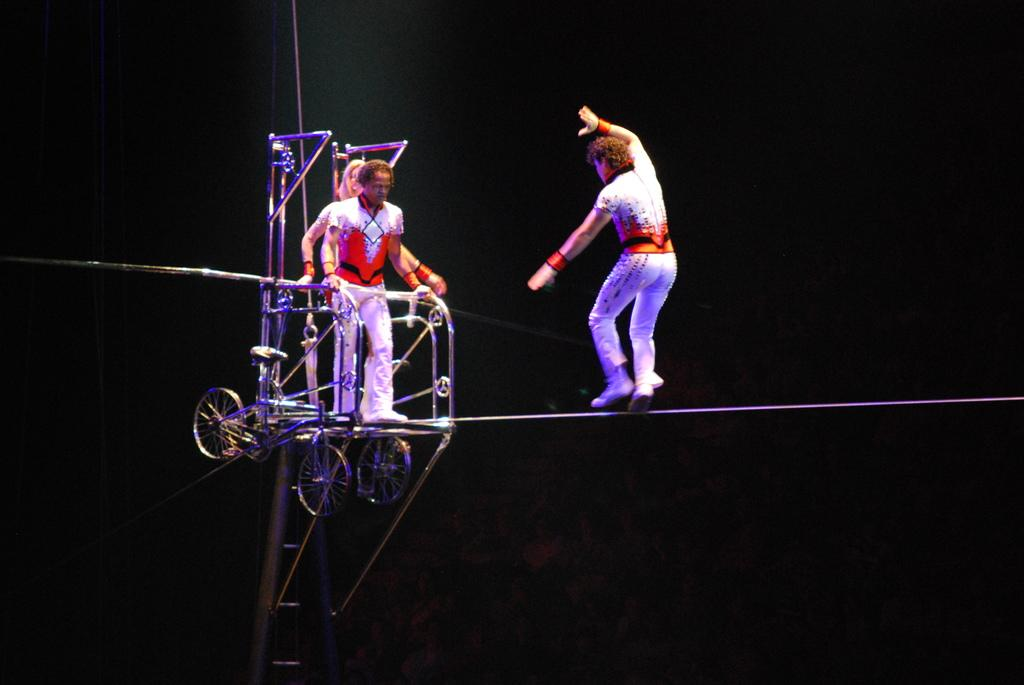How many people are in the image? There are three people in the image. What is the man on a rope doing? The man on a rope is not doing anything specific in the image, but he is on a rope. What type of objects have wheels in the image? The provided facts do not specify which objects have wheels, so we cannot determine that from the information given. What are the rods used for in the image? The purpose of the rods in the image is not specified, so we cannot determine their use from the information given. What can be said about the background of the image? The background of the image is dark. What type of snow can be seen falling in the image? There is no snow present in the image, so we cannot determine if any type of snow is falling. How does the growth of the unspecified objects affect the rhythm of the scene in the image? There are no unspecified objects mentioned as growing, and the concept of rhythm is not applicable to the image based on the provided facts. 